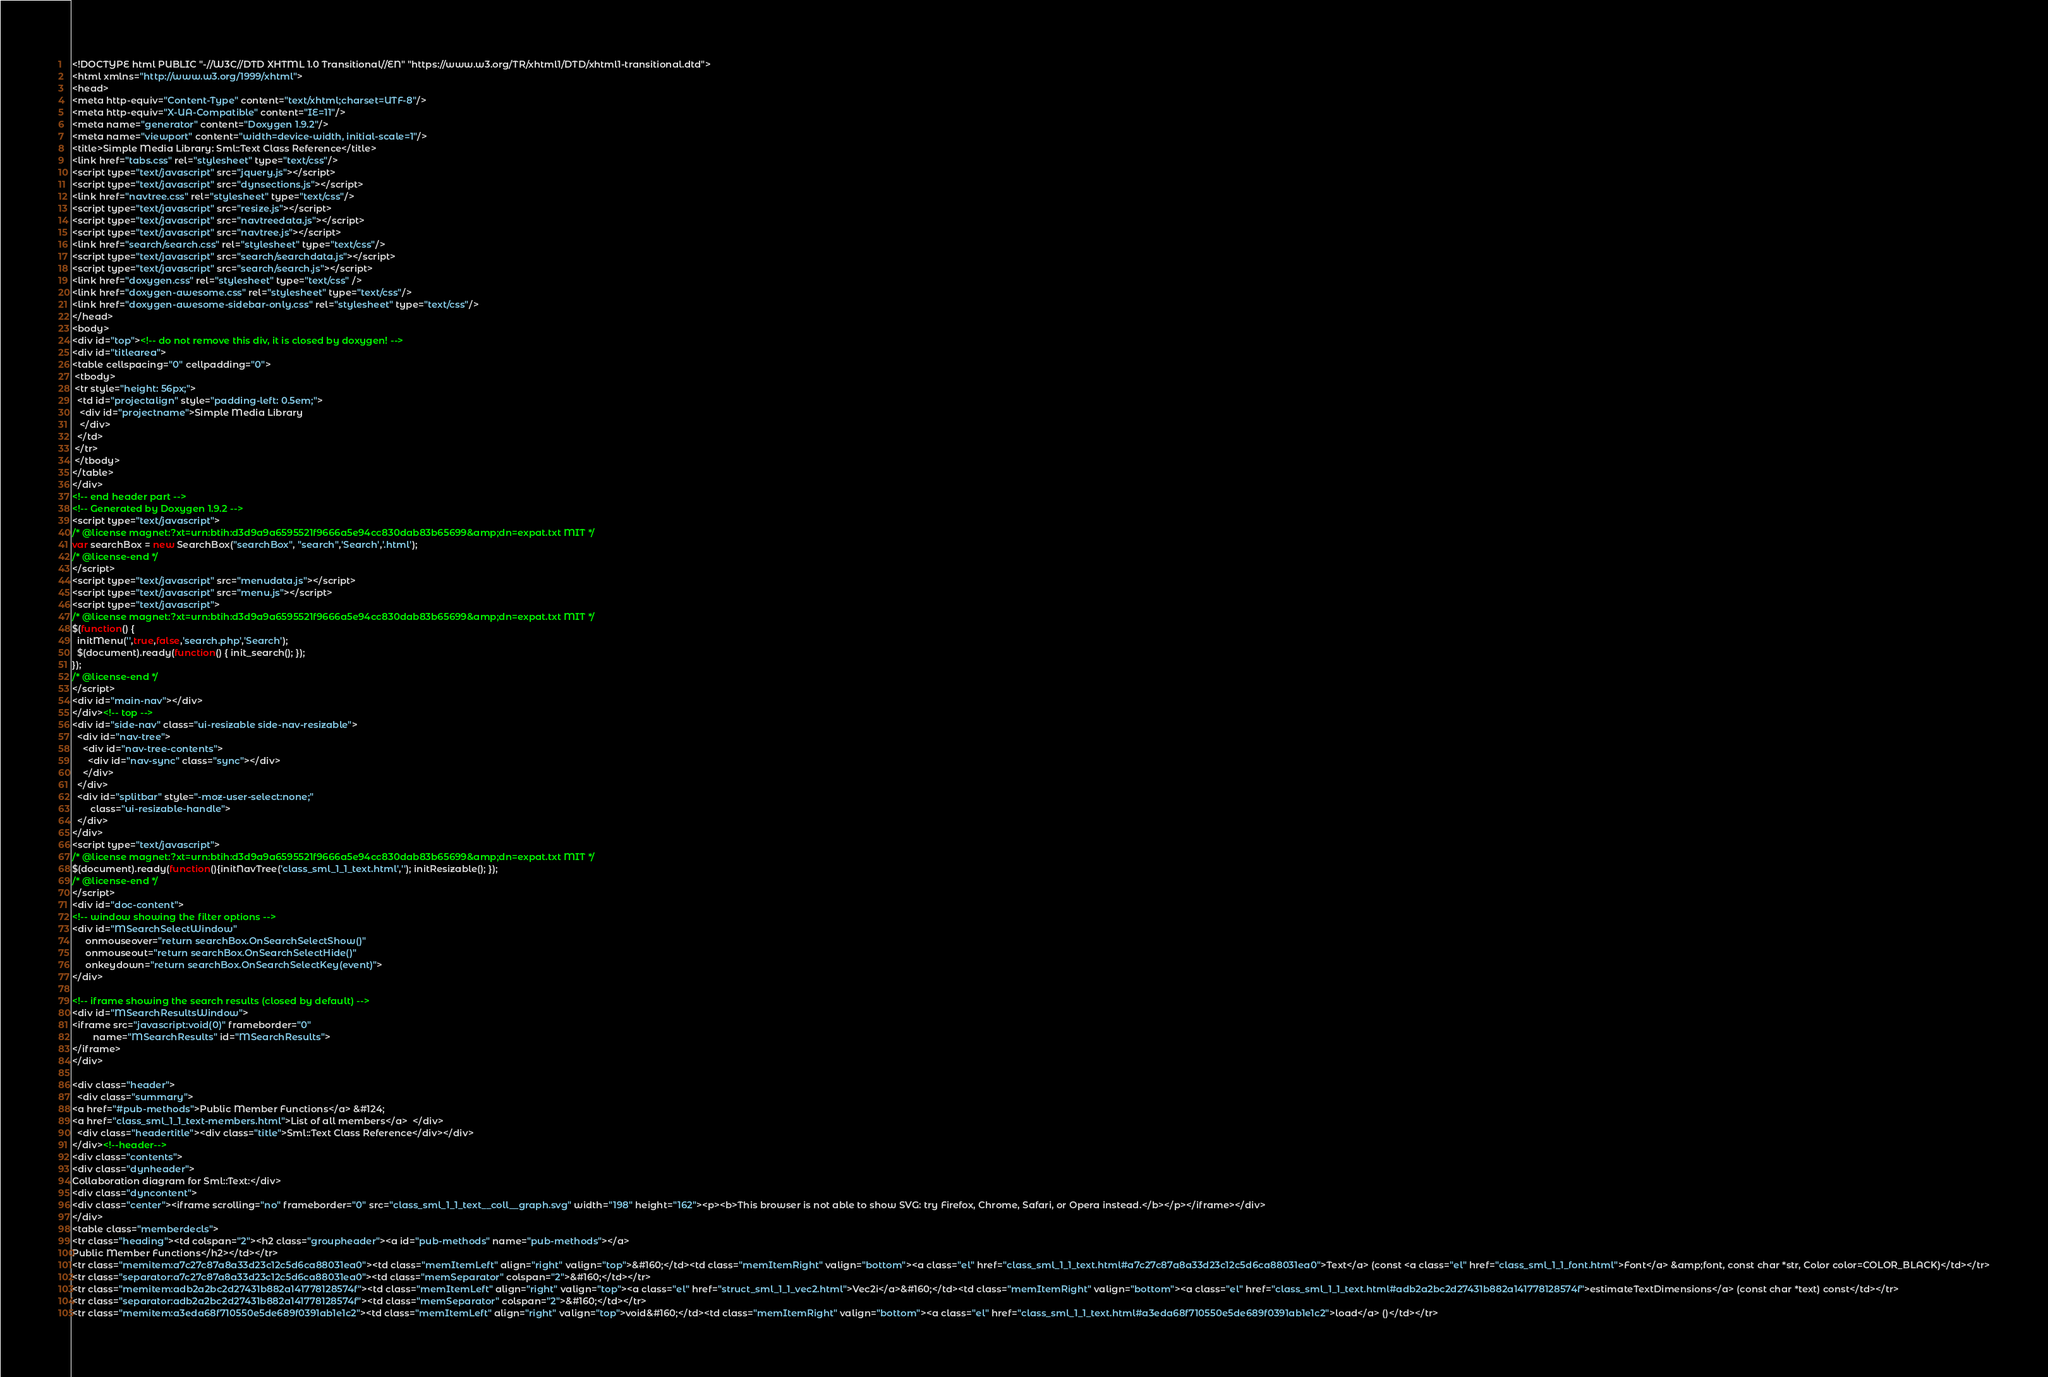<code> <loc_0><loc_0><loc_500><loc_500><_HTML_><!DOCTYPE html PUBLIC "-//W3C//DTD XHTML 1.0 Transitional//EN" "https://www.w3.org/TR/xhtml1/DTD/xhtml1-transitional.dtd">
<html xmlns="http://www.w3.org/1999/xhtml">
<head>
<meta http-equiv="Content-Type" content="text/xhtml;charset=UTF-8"/>
<meta http-equiv="X-UA-Compatible" content="IE=11"/>
<meta name="generator" content="Doxygen 1.9.2"/>
<meta name="viewport" content="width=device-width, initial-scale=1"/>
<title>Simple Media Library: Sml::Text Class Reference</title>
<link href="tabs.css" rel="stylesheet" type="text/css"/>
<script type="text/javascript" src="jquery.js"></script>
<script type="text/javascript" src="dynsections.js"></script>
<link href="navtree.css" rel="stylesheet" type="text/css"/>
<script type="text/javascript" src="resize.js"></script>
<script type="text/javascript" src="navtreedata.js"></script>
<script type="text/javascript" src="navtree.js"></script>
<link href="search/search.css" rel="stylesheet" type="text/css"/>
<script type="text/javascript" src="search/searchdata.js"></script>
<script type="text/javascript" src="search/search.js"></script>
<link href="doxygen.css" rel="stylesheet" type="text/css" />
<link href="doxygen-awesome.css" rel="stylesheet" type="text/css"/>
<link href="doxygen-awesome-sidebar-only.css" rel="stylesheet" type="text/css"/>
</head>
<body>
<div id="top"><!-- do not remove this div, it is closed by doxygen! -->
<div id="titlearea">
<table cellspacing="0" cellpadding="0">
 <tbody>
 <tr style="height: 56px;">
  <td id="projectalign" style="padding-left: 0.5em;">
   <div id="projectname">Simple Media Library
   </div>
  </td>
 </tr>
 </tbody>
</table>
</div>
<!-- end header part -->
<!-- Generated by Doxygen 1.9.2 -->
<script type="text/javascript">
/* @license magnet:?xt=urn:btih:d3d9a9a6595521f9666a5e94cc830dab83b65699&amp;dn=expat.txt MIT */
var searchBox = new SearchBox("searchBox", "search",'Search','.html');
/* @license-end */
</script>
<script type="text/javascript" src="menudata.js"></script>
<script type="text/javascript" src="menu.js"></script>
<script type="text/javascript">
/* @license magnet:?xt=urn:btih:d3d9a9a6595521f9666a5e94cc830dab83b65699&amp;dn=expat.txt MIT */
$(function() {
  initMenu('',true,false,'search.php','Search');
  $(document).ready(function() { init_search(); });
});
/* @license-end */
</script>
<div id="main-nav"></div>
</div><!-- top -->
<div id="side-nav" class="ui-resizable side-nav-resizable">
  <div id="nav-tree">
    <div id="nav-tree-contents">
      <div id="nav-sync" class="sync"></div>
    </div>
  </div>
  <div id="splitbar" style="-moz-user-select:none;" 
       class="ui-resizable-handle">
  </div>
</div>
<script type="text/javascript">
/* @license magnet:?xt=urn:btih:d3d9a9a6595521f9666a5e94cc830dab83b65699&amp;dn=expat.txt MIT */
$(document).ready(function(){initNavTree('class_sml_1_1_text.html',''); initResizable(); });
/* @license-end */
</script>
<div id="doc-content">
<!-- window showing the filter options -->
<div id="MSearchSelectWindow"
     onmouseover="return searchBox.OnSearchSelectShow()"
     onmouseout="return searchBox.OnSearchSelectHide()"
     onkeydown="return searchBox.OnSearchSelectKey(event)">
</div>

<!-- iframe showing the search results (closed by default) -->
<div id="MSearchResultsWindow">
<iframe src="javascript:void(0)" frameborder="0" 
        name="MSearchResults" id="MSearchResults">
</iframe>
</div>

<div class="header">
  <div class="summary">
<a href="#pub-methods">Public Member Functions</a> &#124;
<a href="class_sml_1_1_text-members.html">List of all members</a>  </div>
  <div class="headertitle"><div class="title">Sml::Text Class Reference</div></div>
</div><!--header-->
<div class="contents">
<div class="dynheader">
Collaboration diagram for Sml::Text:</div>
<div class="dyncontent">
<div class="center"><iframe scrolling="no" frameborder="0" src="class_sml_1_1_text__coll__graph.svg" width="198" height="162"><p><b>This browser is not able to show SVG: try Firefox, Chrome, Safari, or Opera instead.</b></p></iframe></div>
</div>
<table class="memberdecls">
<tr class="heading"><td colspan="2"><h2 class="groupheader"><a id="pub-methods" name="pub-methods"></a>
Public Member Functions</h2></td></tr>
<tr class="memitem:a7c27c87a8a33d23c12c5d6ca88031ea0"><td class="memItemLeft" align="right" valign="top">&#160;</td><td class="memItemRight" valign="bottom"><a class="el" href="class_sml_1_1_text.html#a7c27c87a8a33d23c12c5d6ca88031ea0">Text</a> (const <a class="el" href="class_sml_1_1_font.html">Font</a> &amp;font, const char *str, Color color=COLOR_BLACK)</td></tr>
<tr class="separator:a7c27c87a8a33d23c12c5d6ca88031ea0"><td class="memSeparator" colspan="2">&#160;</td></tr>
<tr class="memitem:adb2a2bc2d27431b882a141778128574f"><td class="memItemLeft" align="right" valign="top"><a class="el" href="struct_sml_1_1_vec2.html">Vec2i</a>&#160;</td><td class="memItemRight" valign="bottom"><a class="el" href="class_sml_1_1_text.html#adb2a2bc2d27431b882a141778128574f">estimateTextDimensions</a> (const char *text) const</td></tr>
<tr class="separator:adb2a2bc2d27431b882a141778128574f"><td class="memSeparator" colspan="2">&#160;</td></tr>
<tr class="memitem:a3eda68f710550e5de689f0391ab1e1c2"><td class="memItemLeft" align="right" valign="top">void&#160;</td><td class="memItemRight" valign="bottom"><a class="el" href="class_sml_1_1_text.html#a3eda68f710550e5de689f0391ab1e1c2">load</a> ()</td></tr></code> 